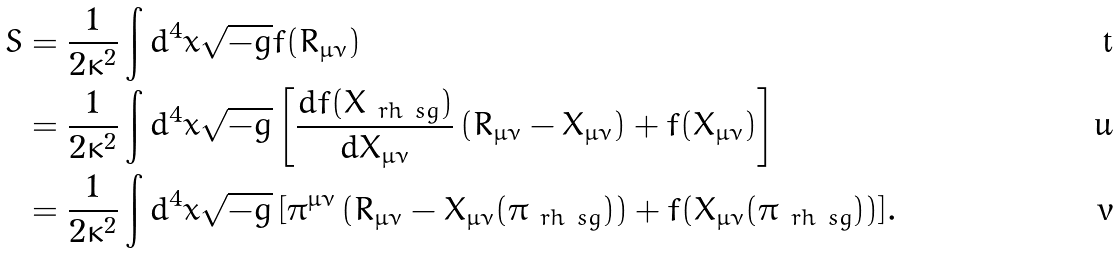Convert formula to latex. <formula><loc_0><loc_0><loc_500><loc_500>S & = \frac { 1 } { 2 \kappa ^ { 2 } } \int { d ^ { 4 } x \sqrt { - g } f ( R _ { \mu \nu } ) } \\ & = \frac { 1 } { 2 \kappa ^ { 2 } } \int { d ^ { 4 } x \sqrt { - g } \left [ \frac { d f ( X _ { \ r h \ s g } ) } { d X _ { \mu \nu } } \left ( R _ { \mu \nu } - X _ { \mu \nu } \right ) + f ( X _ { \mu \nu } ) \right ] } \\ & = \frac { 1 } { 2 \kappa ^ { 2 } } \int { d ^ { 4 } x \sqrt { - g } \left [ \pi ^ { \mu \nu } \left ( R _ { \mu \nu } - X _ { \mu \nu } ( \pi _ { \ r h \ s g } ) \right ) + f ( X _ { \mu \nu } ( \pi _ { \ r h \ s g } ) ) \right ] } .</formula> 